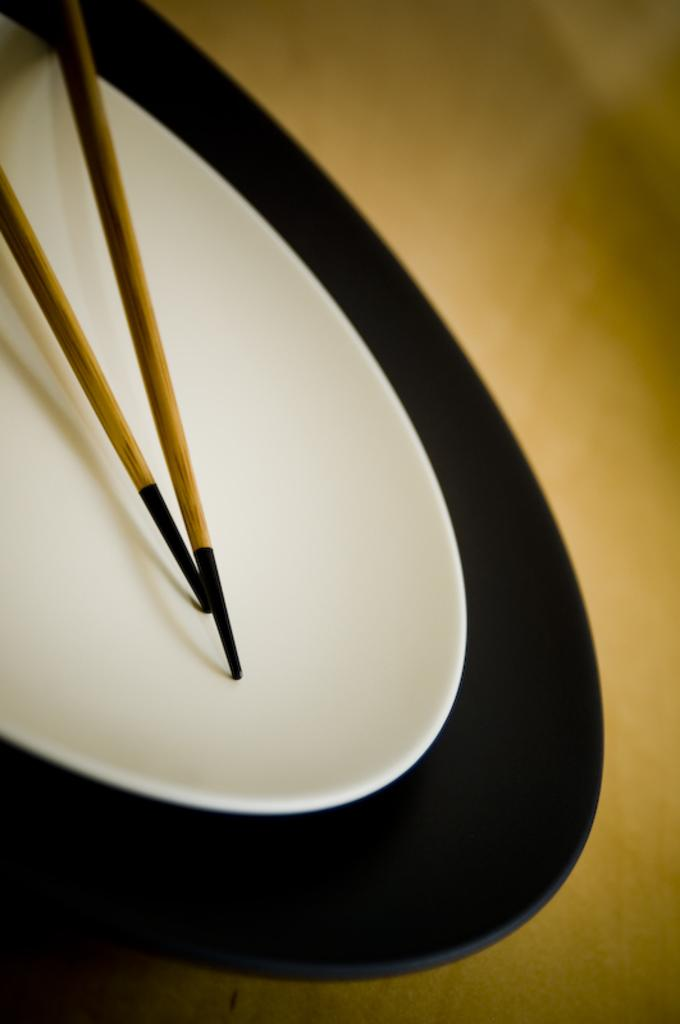How many plates are visible in the image? There are two plates in the image. What else can be seen in the image besides the plates? There are two sticks visible in the image. How many brothers are playing with the dolls in the image? There are no brothers or dolls present in the image. 